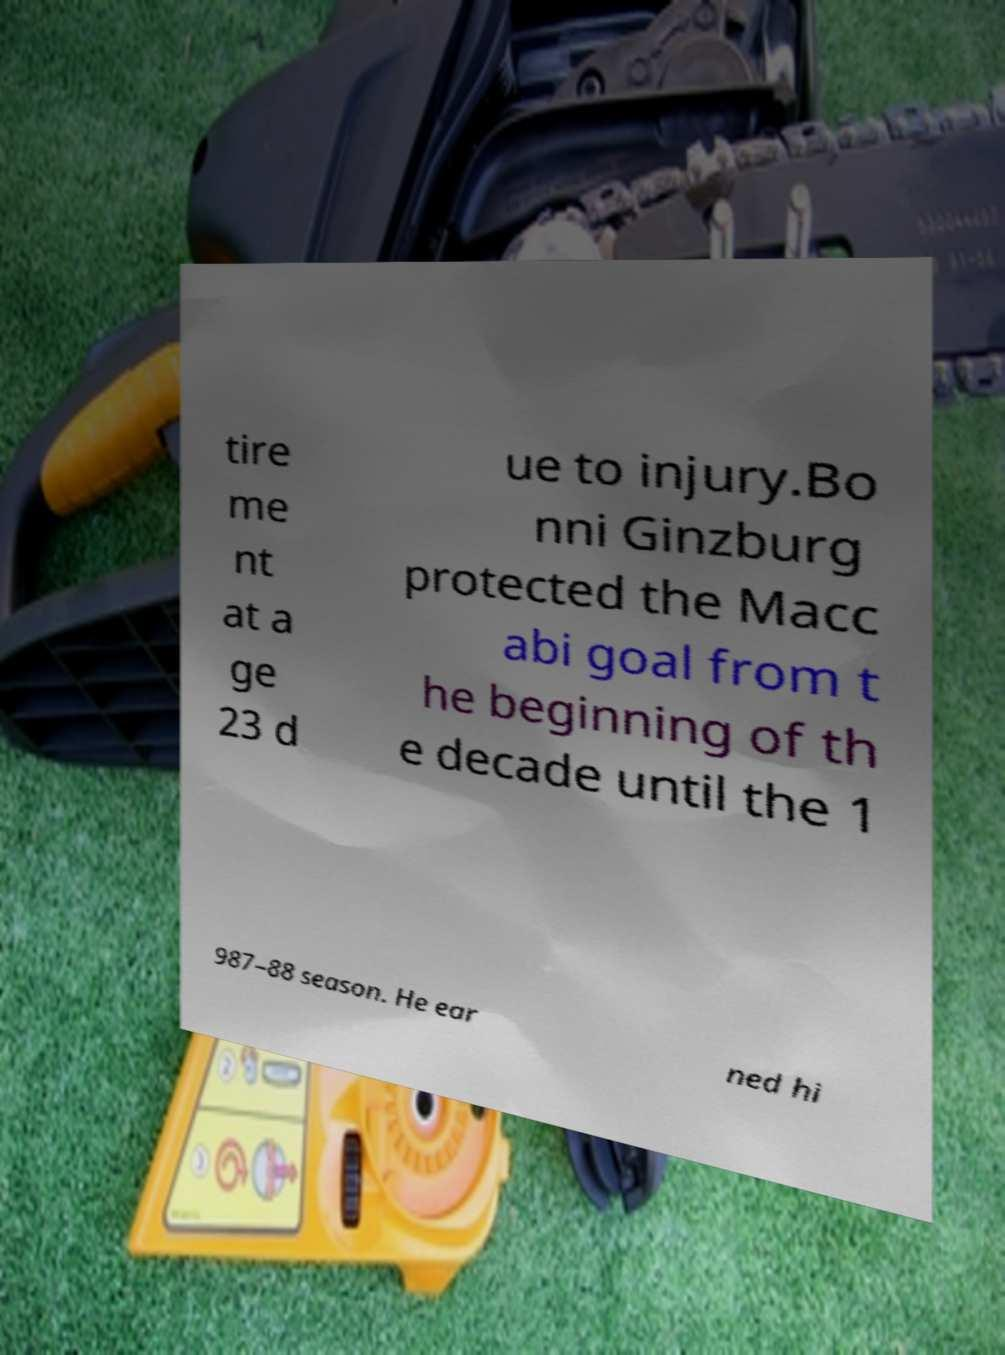Can you accurately transcribe the text from the provided image for me? tire me nt at a ge 23 d ue to injury.Bo nni Ginzburg protected the Macc abi goal from t he beginning of th e decade until the 1 987–88 season. He ear ned hi 